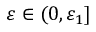<formula> <loc_0><loc_0><loc_500><loc_500>{ \varepsilon } \in ( 0 , { \varepsilon } _ { 1 } ]</formula> 